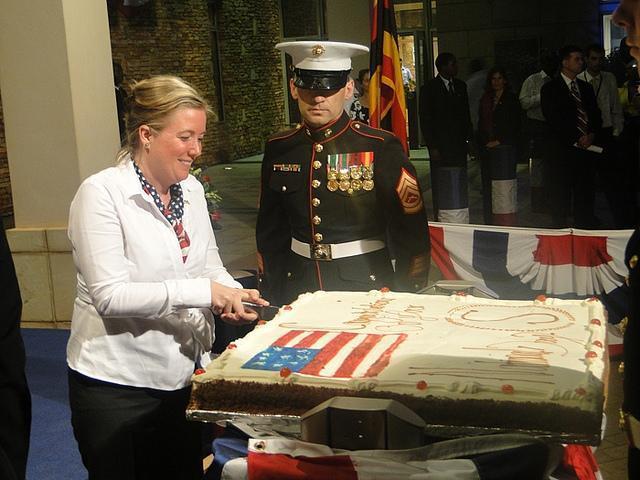How many buntings can be seen in the image?
Give a very brief answer. 2. How many people are in the photo?
Give a very brief answer. 8. 